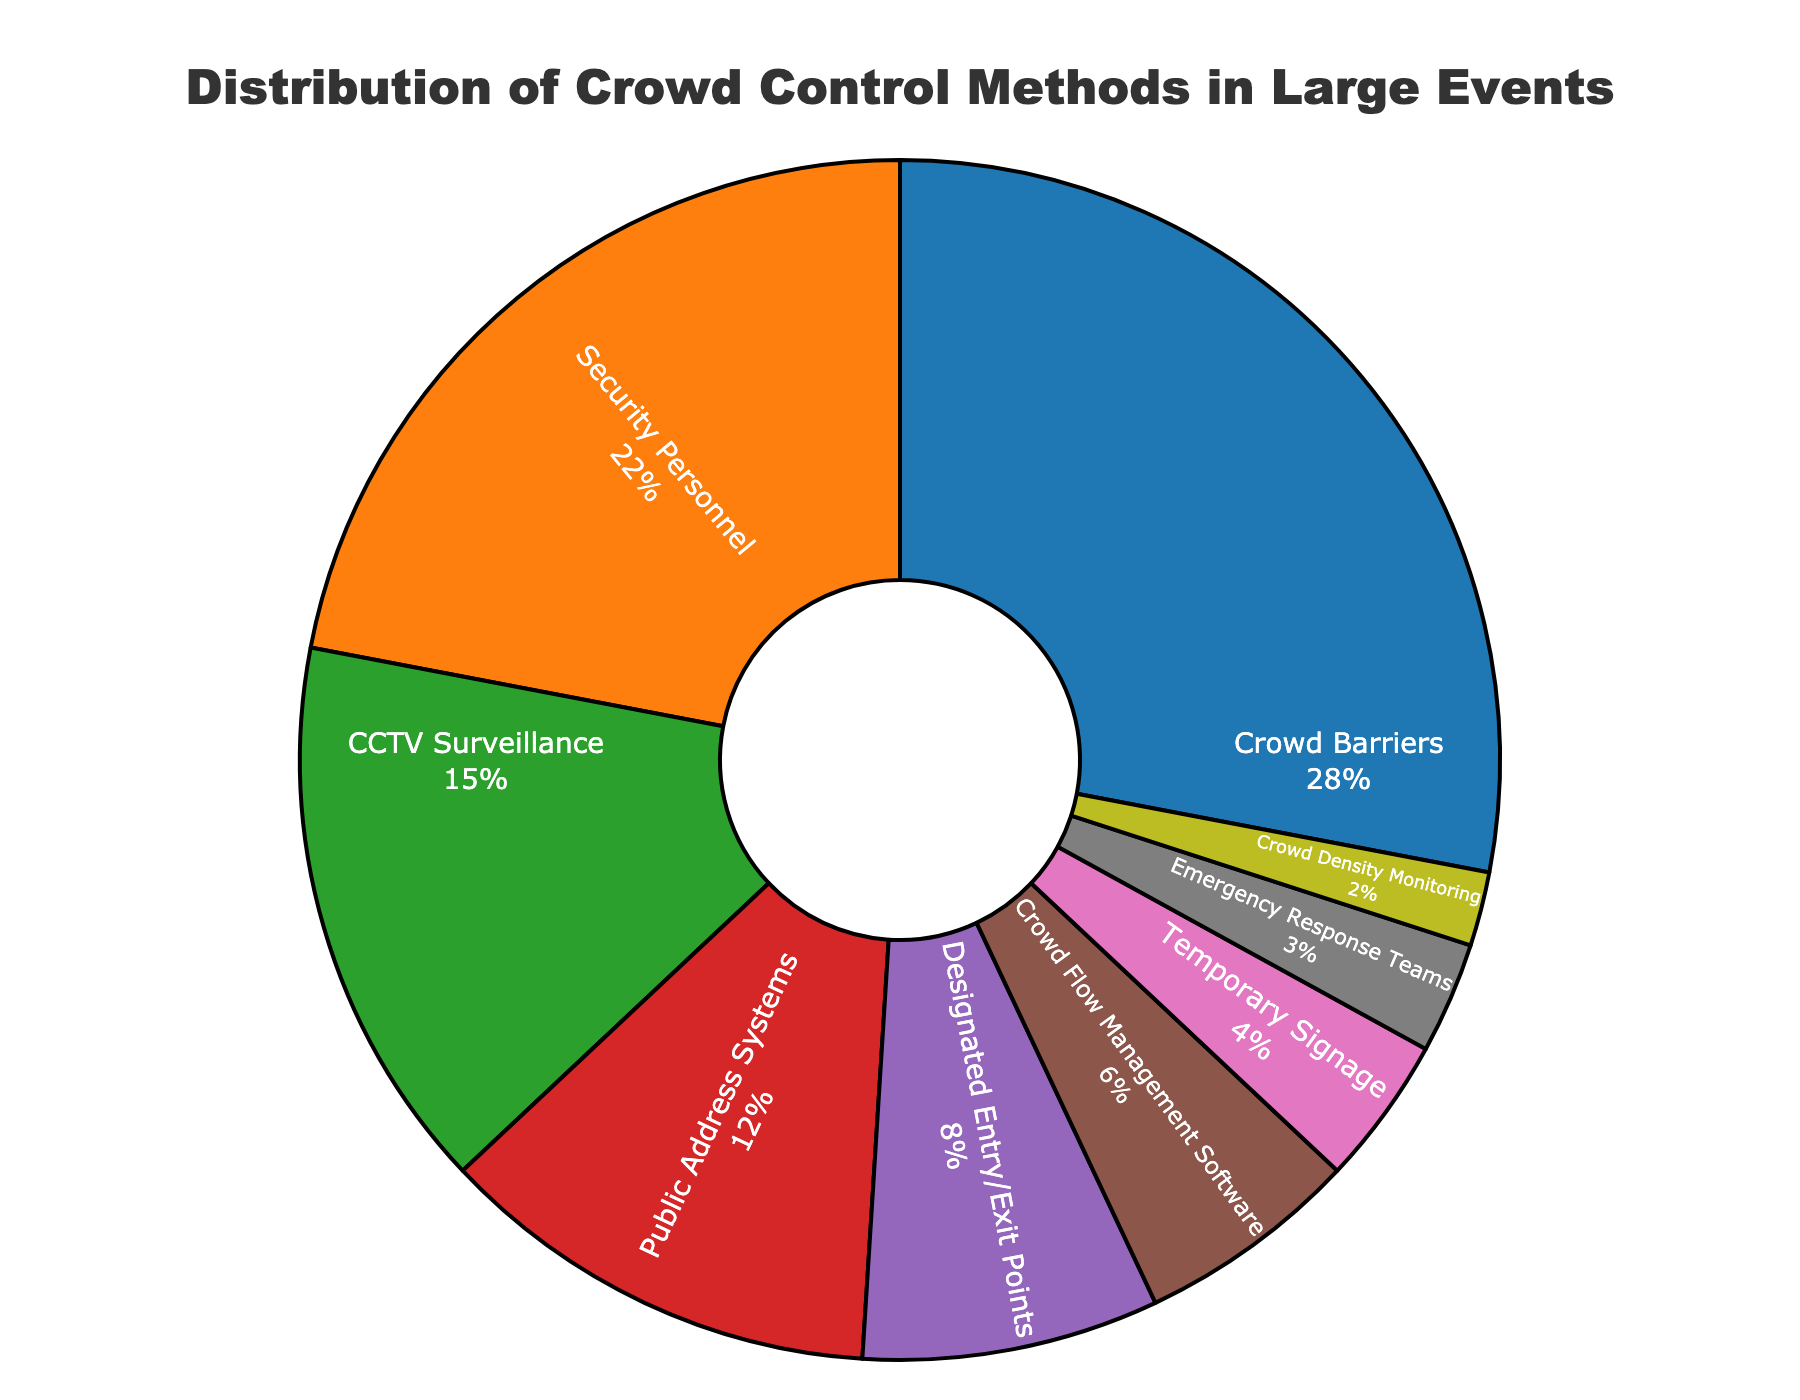What is the most commonly used crowd control method? The most commonly used method is the one with the highest percentage in the pie chart. From the pie chart, Crowd Barriers have the largest segment.
Answer: Crowd Barriers Which two methods together account for 50% of the crowd control methods used? To find two methods that together account for 50%, look at the highest percentages and sum the values. Crowd Barriers (28%) + Security Personnel (22%) = 50%.
Answer: Crowd Barriers and Security Personnel Are Designated Entry/Exit Points used more or less frequently than Temporary Signage? Compare the percentages of Designated Entry/Exit Points and Temporary Signage. Designated Entry/Exit Points are 8%, while Temporary Signage is 4%.
Answer: More By how much does the percentage of CCTV Surveillance exceed that of Emergency Response Teams? Calculate the difference between the percentages of CCTV Surveillance (15%) and Emergency Response Teams (3%). 15% - 3% = 12%.
Answer: 12% What percentage of the crowd control methods is accounted for by the bottom four categories together? Sum the percentages of the four least used methods: Temporary Signage (4%) + Emergency Response Teams (3%) + Crowd Density Monitoring (2%) + Crowd Flow Management Software (6%) = 15%.
Answer: 15% Which method is represented by the smallest segment in the pie chart? Identify the smallest segment based on the percentages shown. Crowd Density Monitoring has the smallest proportion at 2%.
Answer: Crowd Density Monitoring What is the percentage difference between Public Address Systems and the combined total of Emergency Response Teams and Crowd Density Monitoring? Calculate the combined total of Emergency Response Teams (3%) and Crowd Density Monitoring (2%) = 5%. Then, find the difference between Public Address Systems (12%) and this total: 12% - 5% = 7%.
Answer: 7% Which method is used more frequently: Crowd Flow Management Software or Public Address Systems? Compare the percentages of both methods. Crowd Flow Management Software is 6%, and Public Address Systems is 12%.
Answer: Public Address Systems 